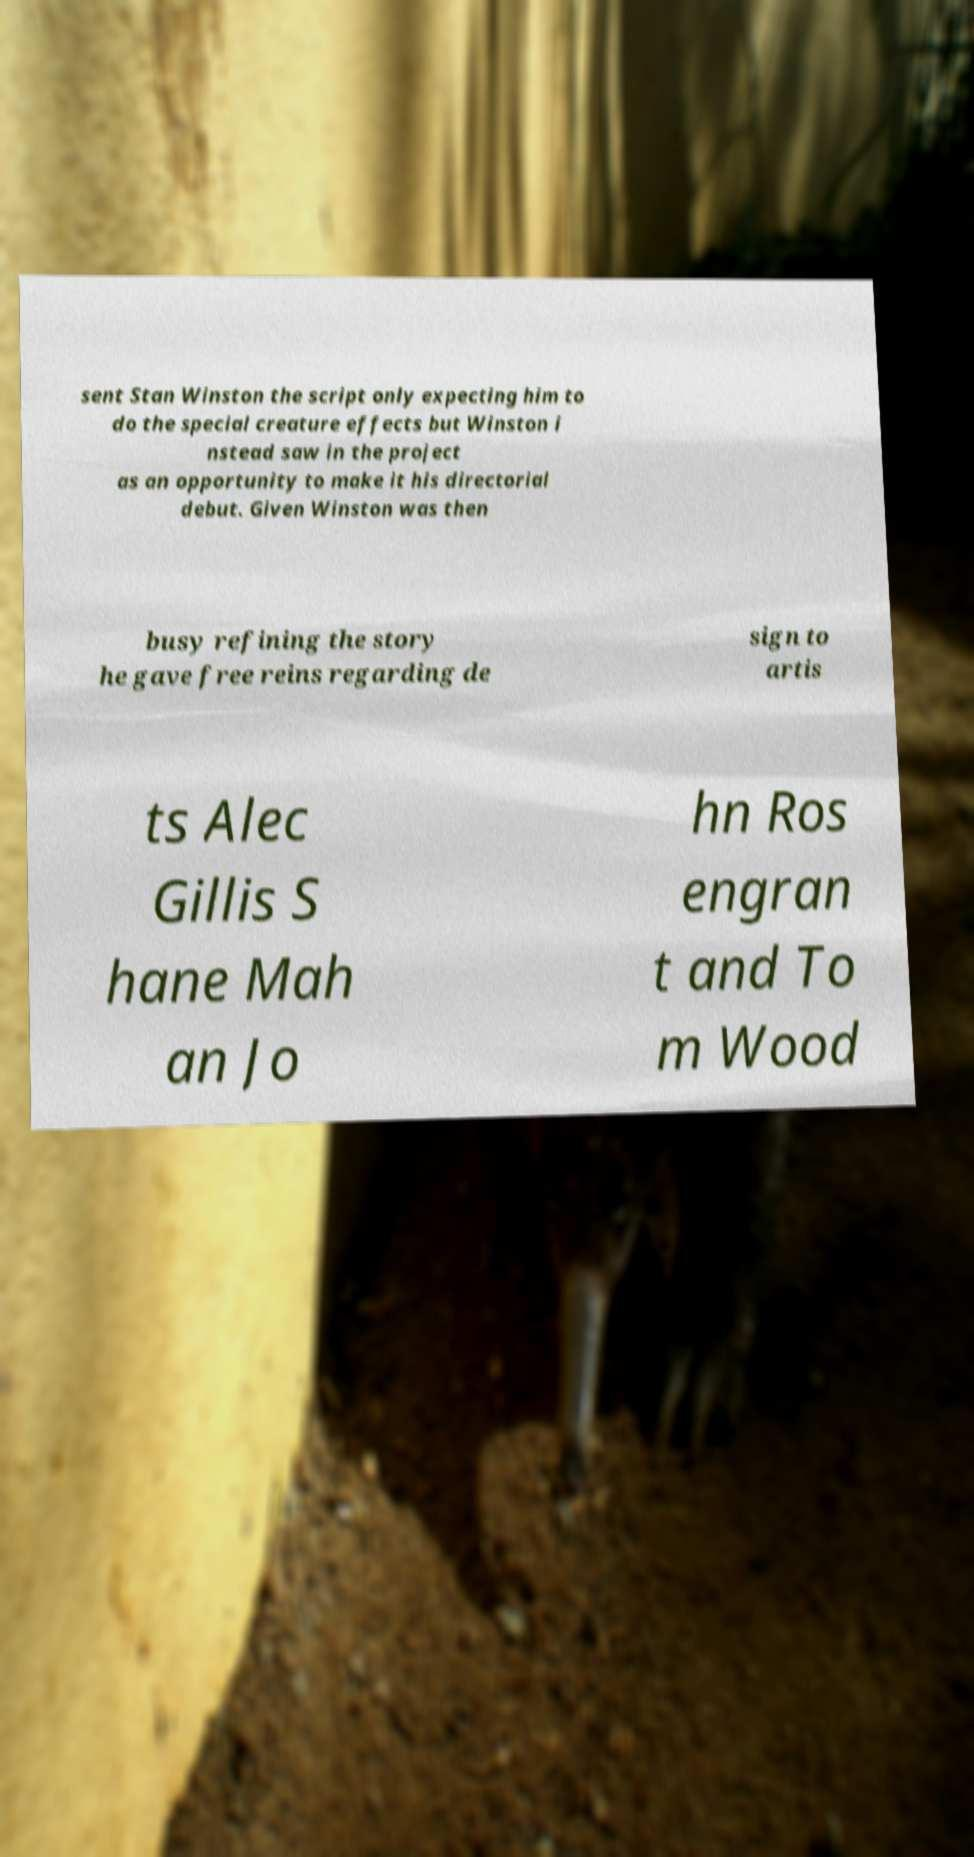Can you read and provide the text displayed in the image?This photo seems to have some interesting text. Can you extract and type it out for me? sent Stan Winston the script only expecting him to do the special creature effects but Winston i nstead saw in the project as an opportunity to make it his directorial debut. Given Winston was then busy refining the story he gave free reins regarding de sign to artis ts Alec Gillis S hane Mah an Jo hn Ros engran t and To m Wood 